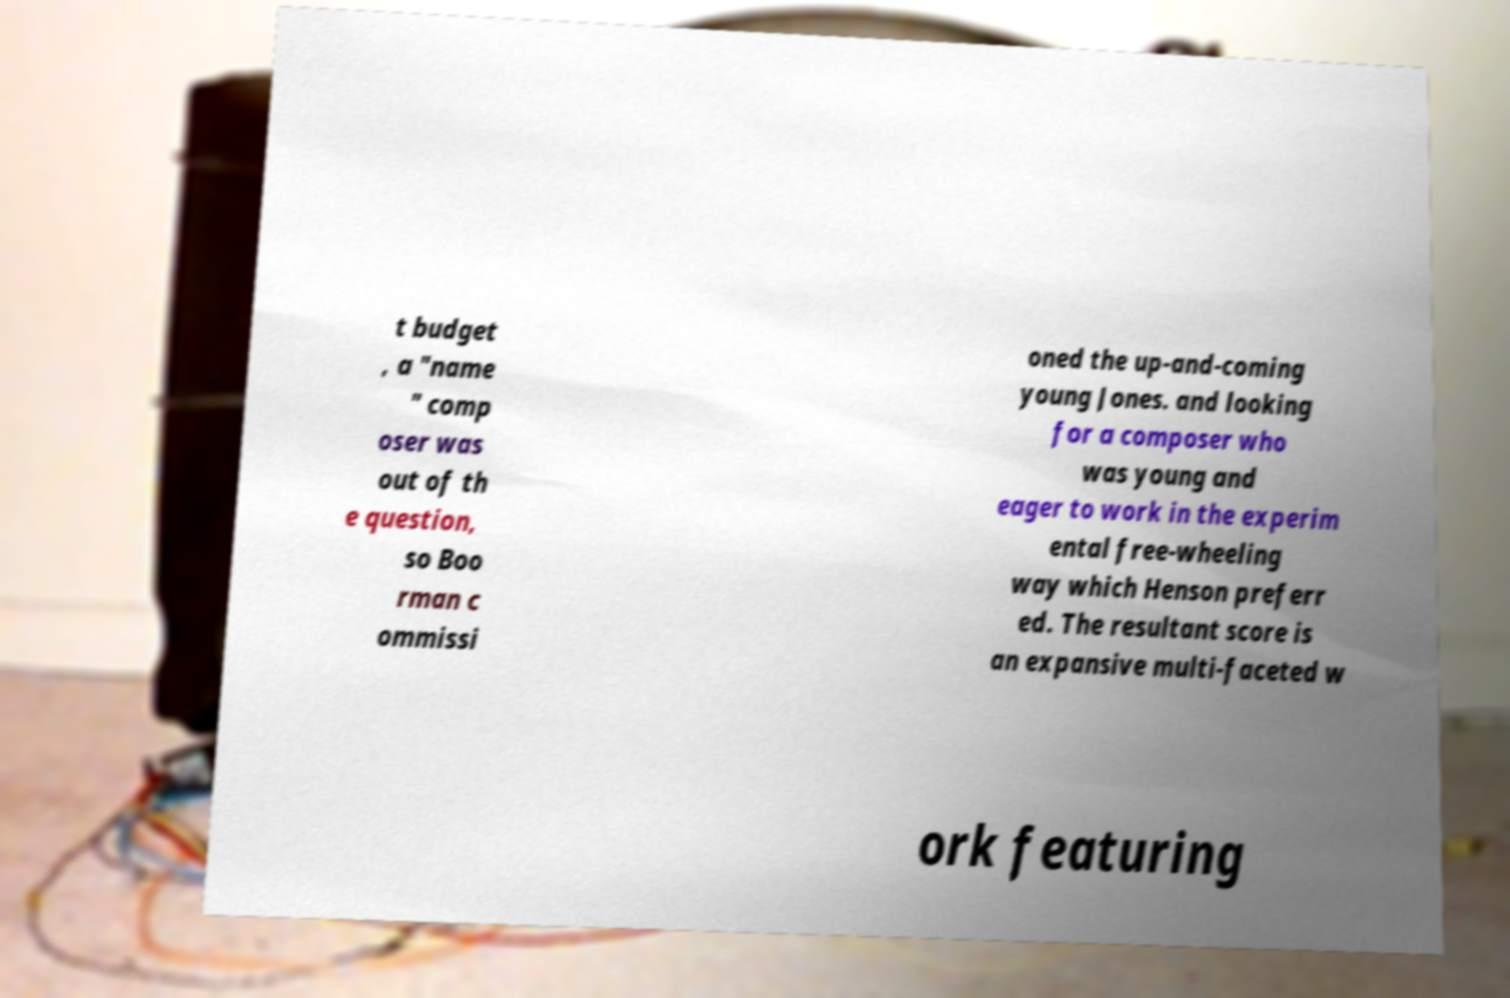For documentation purposes, I need the text within this image transcribed. Could you provide that? t budget , a "name " comp oser was out of th e question, so Boo rman c ommissi oned the up-and-coming young Jones. and looking for a composer who was young and eager to work in the experim ental free-wheeling way which Henson preferr ed. The resultant score is an expansive multi-faceted w ork featuring 